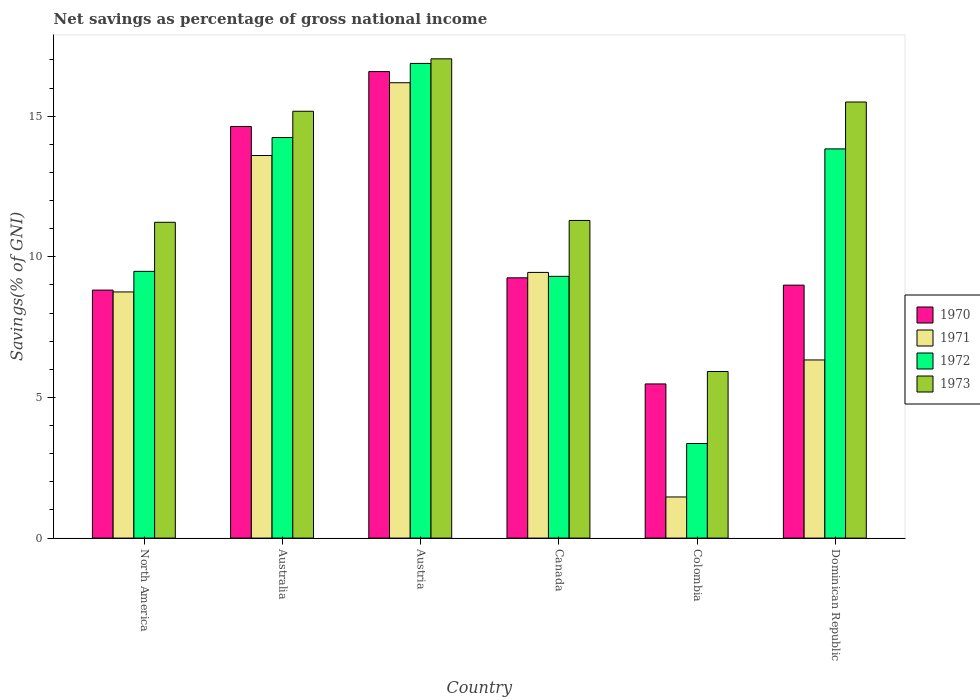How many different coloured bars are there?
Provide a short and direct response. 4. How many groups of bars are there?
Give a very brief answer. 6. Are the number of bars on each tick of the X-axis equal?
Keep it short and to the point. Yes. How many bars are there on the 6th tick from the right?
Your answer should be compact. 4. What is the total savings in 1972 in Colombia?
Ensure brevity in your answer.  3.36. Across all countries, what is the maximum total savings in 1973?
Give a very brief answer. 17.04. Across all countries, what is the minimum total savings in 1973?
Your answer should be compact. 5.92. In which country was the total savings in 1971 maximum?
Your answer should be compact. Austria. What is the total total savings in 1970 in the graph?
Your response must be concise. 63.77. What is the difference between the total savings in 1972 in Austria and that in Dominican Republic?
Your response must be concise. 3.04. What is the difference between the total savings in 1971 in Australia and the total savings in 1972 in Dominican Republic?
Give a very brief answer. -0.24. What is the average total savings in 1972 per country?
Your response must be concise. 11.19. What is the difference between the total savings of/in 1972 and total savings of/in 1971 in North America?
Ensure brevity in your answer.  0.73. What is the ratio of the total savings in 1970 in Canada to that in Dominican Republic?
Give a very brief answer. 1.03. Is the total savings in 1971 in Canada less than that in Dominican Republic?
Make the answer very short. No. What is the difference between the highest and the second highest total savings in 1973?
Give a very brief answer. 1.86. What is the difference between the highest and the lowest total savings in 1973?
Ensure brevity in your answer.  11.12. In how many countries, is the total savings in 1973 greater than the average total savings in 1973 taken over all countries?
Your answer should be very brief. 3. What does the 2nd bar from the right in Austria represents?
Your answer should be compact. 1972. What is the difference between two consecutive major ticks on the Y-axis?
Keep it short and to the point. 5. Does the graph contain grids?
Ensure brevity in your answer.  No. Where does the legend appear in the graph?
Your answer should be compact. Center right. How many legend labels are there?
Your answer should be compact. 4. How are the legend labels stacked?
Your answer should be compact. Vertical. What is the title of the graph?
Make the answer very short. Net savings as percentage of gross national income. What is the label or title of the Y-axis?
Keep it short and to the point. Savings(% of GNI). What is the Savings(% of GNI) of 1970 in North America?
Your answer should be very brief. 8.82. What is the Savings(% of GNI) of 1971 in North America?
Your response must be concise. 8.75. What is the Savings(% of GNI) in 1972 in North America?
Give a very brief answer. 9.48. What is the Savings(% of GNI) in 1973 in North America?
Provide a succinct answer. 11.23. What is the Savings(% of GNI) in 1970 in Australia?
Provide a succinct answer. 14.63. What is the Savings(% of GNI) of 1971 in Australia?
Provide a short and direct response. 13.6. What is the Savings(% of GNI) of 1972 in Australia?
Make the answer very short. 14.24. What is the Savings(% of GNI) of 1973 in Australia?
Make the answer very short. 15.18. What is the Savings(% of GNI) in 1970 in Austria?
Offer a very short reply. 16.59. What is the Savings(% of GNI) of 1971 in Austria?
Offer a very short reply. 16.19. What is the Savings(% of GNI) in 1972 in Austria?
Offer a very short reply. 16.88. What is the Savings(% of GNI) in 1973 in Austria?
Your answer should be very brief. 17.04. What is the Savings(% of GNI) in 1970 in Canada?
Give a very brief answer. 9.25. What is the Savings(% of GNI) of 1971 in Canada?
Offer a terse response. 9.45. What is the Savings(% of GNI) in 1972 in Canada?
Give a very brief answer. 9.31. What is the Savings(% of GNI) of 1973 in Canada?
Make the answer very short. 11.29. What is the Savings(% of GNI) of 1970 in Colombia?
Your answer should be compact. 5.48. What is the Savings(% of GNI) in 1971 in Colombia?
Give a very brief answer. 1.46. What is the Savings(% of GNI) of 1972 in Colombia?
Make the answer very short. 3.36. What is the Savings(% of GNI) in 1973 in Colombia?
Provide a short and direct response. 5.92. What is the Savings(% of GNI) in 1970 in Dominican Republic?
Your response must be concise. 8.99. What is the Savings(% of GNI) in 1971 in Dominican Republic?
Offer a terse response. 6.33. What is the Savings(% of GNI) in 1972 in Dominican Republic?
Provide a succinct answer. 13.84. What is the Savings(% of GNI) of 1973 in Dominican Republic?
Offer a very short reply. 15.5. Across all countries, what is the maximum Savings(% of GNI) of 1970?
Offer a very short reply. 16.59. Across all countries, what is the maximum Savings(% of GNI) of 1971?
Your answer should be compact. 16.19. Across all countries, what is the maximum Savings(% of GNI) in 1972?
Ensure brevity in your answer.  16.88. Across all countries, what is the maximum Savings(% of GNI) in 1973?
Provide a succinct answer. 17.04. Across all countries, what is the minimum Savings(% of GNI) of 1970?
Provide a short and direct response. 5.48. Across all countries, what is the minimum Savings(% of GNI) in 1971?
Your response must be concise. 1.46. Across all countries, what is the minimum Savings(% of GNI) in 1972?
Keep it short and to the point. 3.36. Across all countries, what is the minimum Savings(% of GNI) of 1973?
Your answer should be very brief. 5.92. What is the total Savings(% of GNI) of 1970 in the graph?
Provide a succinct answer. 63.77. What is the total Savings(% of GNI) in 1971 in the graph?
Ensure brevity in your answer.  55.79. What is the total Savings(% of GNI) in 1972 in the graph?
Offer a very short reply. 67.11. What is the total Savings(% of GNI) of 1973 in the graph?
Keep it short and to the point. 76.17. What is the difference between the Savings(% of GNI) of 1970 in North America and that in Australia?
Ensure brevity in your answer.  -5.82. What is the difference between the Savings(% of GNI) of 1971 in North America and that in Australia?
Provide a succinct answer. -4.85. What is the difference between the Savings(% of GNI) of 1972 in North America and that in Australia?
Provide a succinct answer. -4.76. What is the difference between the Savings(% of GNI) in 1973 in North America and that in Australia?
Make the answer very short. -3.95. What is the difference between the Savings(% of GNI) in 1970 in North America and that in Austria?
Offer a terse response. -7.77. What is the difference between the Savings(% of GNI) of 1971 in North America and that in Austria?
Provide a succinct answer. -7.44. What is the difference between the Savings(% of GNI) of 1972 in North America and that in Austria?
Give a very brief answer. -7.39. What is the difference between the Savings(% of GNI) in 1973 in North America and that in Austria?
Provide a succinct answer. -5.81. What is the difference between the Savings(% of GNI) in 1970 in North America and that in Canada?
Give a very brief answer. -0.44. What is the difference between the Savings(% of GNI) of 1971 in North America and that in Canada?
Your answer should be compact. -0.69. What is the difference between the Savings(% of GNI) in 1972 in North America and that in Canada?
Provide a short and direct response. 0.18. What is the difference between the Savings(% of GNI) in 1973 in North America and that in Canada?
Provide a short and direct response. -0.07. What is the difference between the Savings(% of GNI) in 1970 in North America and that in Colombia?
Make the answer very short. 3.34. What is the difference between the Savings(% of GNI) in 1971 in North America and that in Colombia?
Give a very brief answer. 7.29. What is the difference between the Savings(% of GNI) in 1972 in North America and that in Colombia?
Your response must be concise. 6.12. What is the difference between the Savings(% of GNI) of 1973 in North America and that in Colombia?
Provide a succinct answer. 5.31. What is the difference between the Savings(% of GNI) in 1970 in North America and that in Dominican Republic?
Ensure brevity in your answer.  -0.18. What is the difference between the Savings(% of GNI) of 1971 in North America and that in Dominican Republic?
Offer a terse response. 2.42. What is the difference between the Savings(% of GNI) in 1972 in North America and that in Dominican Republic?
Your response must be concise. -4.35. What is the difference between the Savings(% of GNI) in 1973 in North America and that in Dominican Republic?
Keep it short and to the point. -4.28. What is the difference between the Savings(% of GNI) in 1970 in Australia and that in Austria?
Your response must be concise. -1.95. What is the difference between the Savings(% of GNI) of 1971 in Australia and that in Austria?
Your answer should be compact. -2.59. What is the difference between the Savings(% of GNI) in 1972 in Australia and that in Austria?
Make the answer very short. -2.64. What is the difference between the Savings(% of GNI) in 1973 in Australia and that in Austria?
Your answer should be compact. -1.86. What is the difference between the Savings(% of GNI) in 1970 in Australia and that in Canada?
Offer a very short reply. 5.38. What is the difference between the Savings(% of GNI) in 1971 in Australia and that in Canada?
Provide a succinct answer. 4.16. What is the difference between the Savings(% of GNI) in 1972 in Australia and that in Canada?
Your answer should be very brief. 4.93. What is the difference between the Savings(% of GNI) in 1973 in Australia and that in Canada?
Your response must be concise. 3.88. What is the difference between the Savings(% of GNI) of 1970 in Australia and that in Colombia?
Your answer should be very brief. 9.15. What is the difference between the Savings(% of GNI) of 1971 in Australia and that in Colombia?
Your answer should be very brief. 12.14. What is the difference between the Savings(% of GNI) in 1972 in Australia and that in Colombia?
Keep it short and to the point. 10.88. What is the difference between the Savings(% of GNI) of 1973 in Australia and that in Colombia?
Your answer should be very brief. 9.25. What is the difference between the Savings(% of GNI) of 1970 in Australia and that in Dominican Republic?
Offer a very short reply. 5.64. What is the difference between the Savings(% of GNI) in 1971 in Australia and that in Dominican Republic?
Keep it short and to the point. 7.27. What is the difference between the Savings(% of GNI) in 1972 in Australia and that in Dominican Republic?
Provide a short and direct response. 0.4. What is the difference between the Savings(% of GNI) in 1973 in Australia and that in Dominican Republic?
Give a very brief answer. -0.33. What is the difference between the Savings(% of GNI) of 1970 in Austria and that in Canada?
Your answer should be very brief. 7.33. What is the difference between the Savings(% of GNI) in 1971 in Austria and that in Canada?
Provide a succinct answer. 6.74. What is the difference between the Savings(% of GNI) of 1972 in Austria and that in Canada?
Your answer should be very brief. 7.57. What is the difference between the Savings(% of GNI) of 1973 in Austria and that in Canada?
Ensure brevity in your answer.  5.75. What is the difference between the Savings(% of GNI) in 1970 in Austria and that in Colombia?
Provide a succinct answer. 11.11. What is the difference between the Savings(% of GNI) in 1971 in Austria and that in Colombia?
Offer a very short reply. 14.73. What is the difference between the Savings(% of GNI) of 1972 in Austria and that in Colombia?
Provide a short and direct response. 13.51. What is the difference between the Savings(% of GNI) of 1973 in Austria and that in Colombia?
Your response must be concise. 11.12. What is the difference between the Savings(% of GNI) of 1970 in Austria and that in Dominican Republic?
Offer a terse response. 7.59. What is the difference between the Savings(% of GNI) in 1971 in Austria and that in Dominican Republic?
Give a very brief answer. 9.86. What is the difference between the Savings(% of GNI) of 1972 in Austria and that in Dominican Republic?
Ensure brevity in your answer.  3.04. What is the difference between the Savings(% of GNI) of 1973 in Austria and that in Dominican Republic?
Make the answer very short. 1.54. What is the difference between the Savings(% of GNI) in 1970 in Canada and that in Colombia?
Your answer should be very brief. 3.77. What is the difference between the Savings(% of GNI) in 1971 in Canada and that in Colombia?
Provide a short and direct response. 7.98. What is the difference between the Savings(% of GNI) in 1972 in Canada and that in Colombia?
Keep it short and to the point. 5.94. What is the difference between the Savings(% of GNI) in 1973 in Canada and that in Colombia?
Your response must be concise. 5.37. What is the difference between the Savings(% of GNI) in 1970 in Canada and that in Dominican Republic?
Keep it short and to the point. 0.26. What is the difference between the Savings(% of GNI) of 1971 in Canada and that in Dominican Republic?
Make the answer very short. 3.11. What is the difference between the Savings(% of GNI) in 1972 in Canada and that in Dominican Republic?
Offer a terse response. -4.53. What is the difference between the Savings(% of GNI) of 1973 in Canada and that in Dominican Republic?
Provide a short and direct response. -4.21. What is the difference between the Savings(% of GNI) of 1970 in Colombia and that in Dominican Republic?
Make the answer very short. -3.51. What is the difference between the Savings(% of GNI) of 1971 in Colombia and that in Dominican Republic?
Your answer should be compact. -4.87. What is the difference between the Savings(% of GNI) of 1972 in Colombia and that in Dominican Republic?
Keep it short and to the point. -10.47. What is the difference between the Savings(% of GNI) in 1973 in Colombia and that in Dominican Republic?
Offer a terse response. -9.58. What is the difference between the Savings(% of GNI) of 1970 in North America and the Savings(% of GNI) of 1971 in Australia?
Make the answer very short. -4.78. What is the difference between the Savings(% of GNI) in 1970 in North America and the Savings(% of GNI) in 1972 in Australia?
Offer a terse response. -5.42. What is the difference between the Savings(% of GNI) in 1970 in North America and the Savings(% of GNI) in 1973 in Australia?
Provide a succinct answer. -6.36. What is the difference between the Savings(% of GNI) in 1971 in North America and the Savings(% of GNI) in 1972 in Australia?
Offer a terse response. -5.49. What is the difference between the Savings(% of GNI) in 1971 in North America and the Savings(% of GNI) in 1973 in Australia?
Your response must be concise. -6.42. What is the difference between the Savings(% of GNI) of 1972 in North America and the Savings(% of GNI) of 1973 in Australia?
Your response must be concise. -5.69. What is the difference between the Savings(% of GNI) of 1970 in North America and the Savings(% of GNI) of 1971 in Austria?
Make the answer very short. -7.37. What is the difference between the Savings(% of GNI) of 1970 in North America and the Savings(% of GNI) of 1972 in Austria?
Your response must be concise. -8.06. What is the difference between the Savings(% of GNI) of 1970 in North America and the Savings(% of GNI) of 1973 in Austria?
Provide a short and direct response. -8.22. What is the difference between the Savings(% of GNI) of 1971 in North America and the Savings(% of GNI) of 1972 in Austria?
Make the answer very short. -8.12. What is the difference between the Savings(% of GNI) of 1971 in North America and the Savings(% of GNI) of 1973 in Austria?
Give a very brief answer. -8.29. What is the difference between the Savings(% of GNI) of 1972 in North America and the Savings(% of GNI) of 1973 in Austria?
Offer a very short reply. -7.56. What is the difference between the Savings(% of GNI) in 1970 in North America and the Savings(% of GNI) in 1971 in Canada?
Offer a terse response. -0.63. What is the difference between the Savings(% of GNI) in 1970 in North America and the Savings(% of GNI) in 1972 in Canada?
Provide a short and direct response. -0.49. What is the difference between the Savings(% of GNI) in 1970 in North America and the Savings(% of GNI) in 1973 in Canada?
Give a very brief answer. -2.48. What is the difference between the Savings(% of GNI) of 1971 in North America and the Savings(% of GNI) of 1972 in Canada?
Offer a terse response. -0.55. What is the difference between the Savings(% of GNI) of 1971 in North America and the Savings(% of GNI) of 1973 in Canada?
Provide a short and direct response. -2.54. What is the difference between the Savings(% of GNI) in 1972 in North America and the Savings(% of GNI) in 1973 in Canada?
Ensure brevity in your answer.  -1.81. What is the difference between the Savings(% of GNI) in 1970 in North America and the Savings(% of GNI) in 1971 in Colombia?
Your answer should be compact. 7.36. What is the difference between the Savings(% of GNI) in 1970 in North America and the Savings(% of GNI) in 1972 in Colombia?
Ensure brevity in your answer.  5.45. What is the difference between the Savings(% of GNI) of 1970 in North America and the Savings(% of GNI) of 1973 in Colombia?
Give a very brief answer. 2.89. What is the difference between the Savings(% of GNI) in 1971 in North America and the Savings(% of GNI) in 1972 in Colombia?
Your response must be concise. 5.39. What is the difference between the Savings(% of GNI) in 1971 in North America and the Savings(% of GNI) in 1973 in Colombia?
Give a very brief answer. 2.83. What is the difference between the Savings(% of GNI) of 1972 in North America and the Savings(% of GNI) of 1973 in Colombia?
Provide a short and direct response. 3.56. What is the difference between the Savings(% of GNI) of 1970 in North America and the Savings(% of GNI) of 1971 in Dominican Republic?
Give a very brief answer. 2.48. What is the difference between the Savings(% of GNI) of 1970 in North America and the Savings(% of GNI) of 1972 in Dominican Republic?
Keep it short and to the point. -5.02. What is the difference between the Savings(% of GNI) in 1970 in North America and the Savings(% of GNI) in 1973 in Dominican Republic?
Provide a short and direct response. -6.69. What is the difference between the Savings(% of GNI) of 1971 in North America and the Savings(% of GNI) of 1972 in Dominican Republic?
Offer a very short reply. -5.09. What is the difference between the Savings(% of GNI) of 1971 in North America and the Savings(% of GNI) of 1973 in Dominican Republic?
Your answer should be very brief. -6.75. What is the difference between the Savings(% of GNI) in 1972 in North America and the Savings(% of GNI) in 1973 in Dominican Republic?
Give a very brief answer. -6.02. What is the difference between the Savings(% of GNI) of 1970 in Australia and the Savings(% of GNI) of 1971 in Austria?
Your answer should be compact. -1.55. What is the difference between the Savings(% of GNI) in 1970 in Australia and the Savings(% of GNI) in 1972 in Austria?
Provide a succinct answer. -2.24. What is the difference between the Savings(% of GNI) in 1970 in Australia and the Savings(% of GNI) in 1973 in Austria?
Provide a succinct answer. -2.4. What is the difference between the Savings(% of GNI) of 1971 in Australia and the Savings(% of GNI) of 1972 in Austria?
Offer a very short reply. -3.27. What is the difference between the Savings(% of GNI) of 1971 in Australia and the Savings(% of GNI) of 1973 in Austria?
Your response must be concise. -3.44. What is the difference between the Savings(% of GNI) of 1972 in Australia and the Savings(% of GNI) of 1973 in Austria?
Provide a short and direct response. -2.8. What is the difference between the Savings(% of GNI) of 1970 in Australia and the Savings(% of GNI) of 1971 in Canada?
Your response must be concise. 5.19. What is the difference between the Savings(% of GNI) in 1970 in Australia and the Savings(% of GNI) in 1972 in Canada?
Keep it short and to the point. 5.33. What is the difference between the Savings(% of GNI) of 1970 in Australia and the Savings(% of GNI) of 1973 in Canada?
Keep it short and to the point. 3.34. What is the difference between the Savings(% of GNI) in 1971 in Australia and the Savings(% of GNI) in 1972 in Canada?
Give a very brief answer. 4.3. What is the difference between the Savings(% of GNI) in 1971 in Australia and the Savings(% of GNI) in 1973 in Canada?
Ensure brevity in your answer.  2.31. What is the difference between the Savings(% of GNI) in 1972 in Australia and the Savings(% of GNI) in 1973 in Canada?
Provide a succinct answer. 2.95. What is the difference between the Savings(% of GNI) of 1970 in Australia and the Savings(% of GNI) of 1971 in Colombia?
Offer a terse response. 13.17. What is the difference between the Savings(% of GNI) of 1970 in Australia and the Savings(% of GNI) of 1972 in Colombia?
Ensure brevity in your answer.  11.27. What is the difference between the Savings(% of GNI) in 1970 in Australia and the Savings(% of GNI) in 1973 in Colombia?
Keep it short and to the point. 8.71. What is the difference between the Savings(% of GNI) of 1971 in Australia and the Savings(% of GNI) of 1972 in Colombia?
Your response must be concise. 10.24. What is the difference between the Savings(% of GNI) in 1971 in Australia and the Savings(% of GNI) in 1973 in Colombia?
Offer a terse response. 7.68. What is the difference between the Savings(% of GNI) of 1972 in Australia and the Savings(% of GNI) of 1973 in Colombia?
Your answer should be very brief. 8.32. What is the difference between the Savings(% of GNI) of 1970 in Australia and the Savings(% of GNI) of 1971 in Dominican Republic?
Offer a very short reply. 8.3. What is the difference between the Savings(% of GNI) of 1970 in Australia and the Savings(% of GNI) of 1972 in Dominican Republic?
Your answer should be compact. 0.8. What is the difference between the Savings(% of GNI) in 1970 in Australia and the Savings(% of GNI) in 1973 in Dominican Republic?
Offer a terse response. -0.87. What is the difference between the Savings(% of GNI) in 1971 in Australia and the Savings(% of GNI) in 1972 in Dominican Republic?
Provide a succinct answer. -0.24. What is the difference between the Savings(% of GNI) in 1971 in Australia and the Savings(% of GNI) in 1973 in Dominican Republic?
Keep it short and to the point. -1.9. What is the difference between the Savings(% of GNI) in 1972 in Australia and the Savings(% of GNI) in 1973 in Dominican Republic?
Your answer should be compact. -1.26. What is the difference between the Savings(% of GNI) in 1970 in Austria and the Savings(% of GNI) in 1971 in Canada?
Your answer should be very brief. 7.14. What is the difference between the Savings(% of GNI) of 1970 in Austria and the Savings(% of GNI) of 1972 in Canada?
Give a very brief answer. 7.28. What is the difference between the Savings(% of GNI) of 1970 in Austria and the Savings(% of GNI) of 1973 in Canada?
Your answer should be very brief. 5.29. What is the difference between the Savings(% of GNI) in 1971 in Austria and the Savings(% of GNI) in 1972 in Canada?
Your response must be concise. 6.88. What is the difference between the Savings(% of GNI) in 1971 in Austria and the Savings(% of GNI) in 1973 in Canada?
Provide a succinct answer. 4.9. What is the difference between the Savings(% of GNI) of 1972 in Austria and the Savings(% of GNI) of 1973 in Canada?
Offer a terse response. 5.58. What is the difference between the Savings(% of GNI) in 1970 in Austria and the Savings(% of GNI) in 1971 in Colombia?
Keep it short and to the point. 15.12. What is the difference between the Savings(% of GNI) in 1970 in Austria and the Savings(% of GNI) in 1972 in Colombia?
Make the answer very short. 13.22. What is the difference between the Savings(% of GNI) of 1970 in Austria and the Savings(% of GNI) of 1973 in Colombia?
Ensure brevity in your answer.  10.66. What is the difference between the Savings(% of GNI) of 1971 in Austria and the Savings(% of GNI) of 1972 in Colombia?
Provide a short and direct response. 12.83. What is the difference between the Savings(% of GNI) in 1971 in Austria and the Savings(% of GNI) in 1973 in Colombia?
Ensure brevity in your answer.  10.27. What is the difference between the Savings(% of GNI) in 1972 in Austria and the Savings(% of GNI) in 1973 in Colombia?
Make the answer very short. 10.95. What is the difference between the Savings(% of GNI) in 1970 in Austria and the Savings(% of GNI) in 1971 in Dominican Republic?
Offer a very short reply. 10.25. What is the difference between the Savings(% of GNI) in 1970 in Austria and the Savings(% of GNI) in 1972 in Dominican Republic?
Keep it short and to the point. 2.75. What is the difference between the Savings(% of GNI) of 1970 in Austria and the Savings(% of GNI) of 1973 in Dominican Republic?
Your answer should be compact. 1.08. What is the difference between the Savings(% of GNI) of 1971 in Austria and the Savings(% of GNI) of 1972 in Dominican Republic?
Offer a terse response. 2.35. What is the difference between the Savings(% of GNI) of 1971 in Austria and the Savings(% of GNI) of 1973 in Dominican Republic?
Your response must be concise. 0.69. What is the difference between the Savings(% of GNI) of 1972 in Austria and the Savings(% of GNI) of 1973 in Dominican Republic?
Your answer should be very brief. 1.37. What is the difference between the Savings(% of GNI) in 1970 in Canada and the Savings(% of GNI) in 1971 in Colombia?
Your answer should be compact. 7.79. What is the difference between the Savings(% of GNI) in 1970 in Canada and the Savings(% of GNI) in 1972 in Colombia?
Provide a succinct answer. 5.89. What is the difference between the Savings(% of GNI) of 1970 in Canada and the Savings(% of GNI) of 1973 in Colombia?
Your response must be concise. 3.33. What is the difference between the Savings(% of GNI) in 1971 in Canada and the Savings(% of GNI) in 1972 in Colombia?
Keep it short and to the point. 6.08. What is the difference between the Savings(% of GNI) of 1971 in Canada and the Savings(% of GNI) of 1973 in Colombia?
Your response must be concise. 3.52. What is the difference between the Savings(% of GNI) in 1972 in Canada and the Savings(% of GNI) in 1973 in Colombia?
Provide a short and direct response. 3.38. What is the difference between the Savings(% of GNI) of 1970 in Canada and the Savings(% of GNI) of 1971 in Dominican Republic?
Your response must be concise. 2.92. What is the difference between the Savings(% of GNI) in 1970 in Canada and the Savings(% of GNI) in 1972 in Dominican Republic?
Provide a short and direct response. -4.58. What is the difference between the Savings(% of GNI) in 1970 in Canada and the Savings(% of GNI) in 1973 in Dominican Republic?
Your response must be concise. -6.25. What is the difference between the Savings(% of GNI) of 1971 in Canada and the Savings(% of GNI) of 1972 in Dominican Republic?
Make the answer very short. -4.39. What is the difference between the Savings(% of GNI) of 1971 in Canada and the Savings(% of GNI) of 1973 in Dominican Republic?
Your response must be concise. -6.06. What is the difference between the Savings(% of GNI) of 1972 in Canada and the Savings(% of GNI) of 1973 in Dominican Republic?
Provide a succinct answer. -6.2. What is the difference between the Savings(% of GNI) in 1970 in Colombia and the Savings(% of GNI) in 1971 in Dominican Republic?
Offer a very short reply. -0.85. What is the difference between the Savings(% of GNI) of 1970 in Colombia and the Savings(% of GNI) of 1972 in Dominican Republic?
Ensure brevity in your answer.  -8.36. What is the difference between the Savings(% of GNI) in 1970 in Colombia and the Savings(% of GNI) in 1973 in Dominican Republic?
Make the answer very short. -10.02. What is the difference between the Savings(% of GNI) in 1971 in Colombia and the Savings(% of GNI) in 1972 in Dominican Republic?
Ensure brevity in your answer.  -12.38. What is the difference between the Savings(% of GNI) in 1971 in Colombia and the Savings(% of GNI) in 1973 in Dominican Republic?
Keep it short and to the point. -14.04. What is the difference between the Savings(% of GNI) in 1972 in Colombia and the Savings(% of GNI) in 1973 in Dominican Republic?
Your answer should be very brief. -12.14. What is the average Savings(% of GNI) of 1970 per country?
Your answer should be very brief. 10.63. What is the average Savings(% of GNI) of 1971 per country?
Offer a terse response. 9.3. What is the average Savings(% of GNI) of 1972 per country?
Keep it short and to the point. 11.19. What is the average Savings(% of GNI) of 1973 per country?
Your response must be concise. 12.69. What is the difference between the Savings(% of GNI) in 1970 and Savings(% of GNI) in 1971 in North America?
Give a very brief answer. 0.07. What is the difference between the Savings(% of GNI) in 1970 and Savings(% of GNI) in 1972 in North America?
Provide a short and direct response. -0.67. What is the difference between the Savings(% of GNI) in 1970 and Savings(% of GNI) in 1973 in North America?
Your answer should be compact. -2.41. What is the difference between the Savings(% of GNI) of 1971 and Savings(% of GNI) of 1972 in North America?
Your answer should be very brief. -0.73. What is the difference between the Savings(% of GNI) of 1971 and Savings(% of GNI) of 1973 in North America?
Your answer should be compact. -2.48. What is the difference between the Savings(% of GNI) in 1972 and Savings(% of GNI) in 1973 in North America?
Ensure brevity in your answer.  -1.74. What is the difference between the Savings(% of GNI) of 1970 and Savings(% of GNI) of 1971 in Australia?
Your answer should be compact. 1.03. What is the difference between the Savings(% of GNI) in 1970 and Savings(% of GNI) in 1972 in Australia?
Your answer should be compact. 0.39. What is the difference between the Savings(% of GNI) of 1970 and Savings(% of GNI) of 1973 in Australia?
Ensure brevity in your answer.  -0.54. What is the difference between the Savings(% of GNI) in 1971 and Savings(% of GNI) in 1972 in Australia?
Give a very brief answer. -0.64. What is the difference between the Savings(% of GNI) in 1971 and Savings(% of GNI) in 1973 in Australia?
Your response must be concise. -1.57. What is the difference between the Savings(% of GNI) of 1972 and Savings(% of GNI) of 1973 in Australia?
Offer a very short reply. -0.93. What is the difference between the Savings(% of GNI) of 1970 and Savings(% of GNI) of 1971 in Austria?
Your answer should be compact. 0.4. What is the difference between the Savings(% of GNI) in 1970 and Savings(% of GNI) in 1972 in Austria?
Offer a very short reply. -0.29. What is the difference between the Savings(% of GNI) of 1970 and Savings(% of GNI) of 1973 in Austria?
Your answer should be very brief. -0.45. What is the difference between the Savings(% of GNI) in 1971 and Savings(% of GNI) in 1972 in Austria?
Provide a short and direct response. -0.69. What is the difference between the Savings(% of GNI) of 1971 and Savings(% of GNI) of 1973 in Austria?
Offer a terse response. -0.85. What is the difference between the Savings(% of GNI) in 1972 and Savings(% of GNI) in 1973 in Austria?
Provide a short and direct response. -0.16. What is the difference between the Savings(% of GNI) of 1970 and Savings(% of GNI) of 1971 in Canada?
Offer a terse response. -0.19. What is the difference between the Savings(% of GNI) of 1970 and Savings(% of GNI) of 1972 in Canada?
Your answer should be compact. -0.05. What is the difference between the Savings(% of GNI) of 1970 and Savings(% of GNI) of 1973 in Canada?
Offer a terse response. -2.04. What is the difference between the Savings(% of GNI) of 1971 and Savings(% of GNI) of 1972 in Canada?
Your response must be concise. 0.14. What is the difference between the Savings(% of GNI) in 1971 and Savings(% of GNI) in 1973 in Canada?
Your answer should be very brief. -1.85. What is the difference between the Savings(% of GNI) in 1972 and Savings(% of GNI) in 1973 in Canada?
Your answer should be very brief. -1.99. What is the difference between the Savings(% of GNI) in 1970 and Savings(% of GNI) in 1971 in Colombia?
Offer a very short reply. 4.02. What is the difference between the Savings(% of GNI) of 1970 and Savings(% of GNI) of 1972 in Colombia?
Offer a very short reply. 2.12. What is the difference between the Savings(% of GNI) in 1970 and Savings(% of GNI) in 1973 in Colombia?
Offer a very short reply. -0.44. What is the difference between the Savings(% of GNI) in 1971 and Savings(% of GNI) in 1972 in Colombia?
Give a very brief answer. -1.9. What is the difference between the Savings(% of GNI) of 1971 and Savings(% of GNI) of 1973 in Colombia?
Make the answer very short. -4.46. What is the difference between the Savings(% of GNI) in 1972 and Savings(% of GNI) in 1973 in Colombia?
Make the answer very short. -2.56. What is the difference between the Savings(% of GNI) of 1970 and Savings(% of GNI) of 1971 in Dominican Republic?
Offer a very short reply. 2.66. What is the difference between the Savings(% of GNI) of 1970 and Savings(% of GNI) of 1972 in Dominican Republic?
Ensure brevity in your answer.  -4.84. What is the difference between the Savings(% of GNI) in 1970 and Savings(% of GNI) in 1973 in Dominican Republic?
Offer a terse response. -6.51. What is the difference between the Savings(% of GNI) in 1971 and Savings(% of GNI) in 1972 in Dominican Republic?
Make the answer very short. -7.5. What is the difference between the Savings(% of GNI) in 1971 and Savings(% of GNI) in 1973 in Dominican Republic?
Your answer should be compact. -9.17. What is the difference between the Savings(% of GNI) in 1972 and Savings(% of GNI) in 1973 in Dominican Republic?
Offer a terse response. -1.67. What is the ratio of the Savings(% of GNI) of 1970 in North America to that in Australia?
Offer a very short reply. 0.6. What is the ratio of the Savings(% of GNI) in 1971 in North America to that in Australia?
Your answer should be very brief. 0.64. What is the ratio of the Savings(% of GNI) in 1972 in North America to that in Australia?
Provide a short and direct response. 0.67. What is the ratio of the Savings(% of GNI) of 1973 in North America to that in Australia?
Keep it short and to the point. 0.74. What is the ratio of the Savings(% of GNI) in 1970 in North America to that in Austria?
Provide a succinct answer. 0.53. What is the ratio of the Savings(% of GNI) in 1971 in North America to that in Austria?
Ensure brevity in your answer.  0.54. What is the ratio of the Savings(% of GNI) in 1972 in North America to that in Austria?
Give a very brief answer. 0.56. What is the ratio of the Savings(% of GNI) of 1973 in North America to that in Austria?
Provide a succinct answer. 0.66. What is the ratio of the Savings(% of GNI) of 1970 in North America to that in Canada?
Keep it short and to the point. 0.95. What is the ratio of the Savings(% of GNI) of 1971 in North America to that in Canada?
Ensure brevity in your answer.  0.93. What is the ratio of the Savings(% of GNI) of 1972 in North America to that in Canada?
Your response must be concise. 1.02. What is the ratio of the Savings(% of GNI) of 1970 in North America to that in Colombia?
Make the answer very short. 1.61. What is the ratio of the Savings(% of GNI) in 1971 in North America to that in Colombia?
Ensure brevity in your answer.  5.98. What is the ratio of the Savings(% of GNI) in 1972 in North America to that in Colombia?
Your answer should be compact. 2.82. What is the ratio of the Savings(% of GNI) of 1973 in North America to that in Colombia?
Provide a succinct answer. 1.9. What is the ratio of the Savings(% of GNI) in 1970 in North America to that in Dominican Republic?
Offer a very short reply. 0.98. What is the ratio of the Savings(% of GNI) in 1971 in North America to that in Dominican Republic?
Make the answer very short. 1.38. What is the ratio of the Savings(% of GNI) of 1972 in North America to that in Dominican Republic?
Make the answer very short. 0.69. What is the ratio of the Savings(% of GNI) of 1973 in North America to that in Dominican Republic?
Provide a succinct answer. 0.72. What is the ratio of the Savings(% of GNI) of 1970 in Australia to that in Austria?
Keep it short and to the point. 0.88. What is the ratio of the Savings(% of GNI) in 1971 in Australia to that in Austria?
Offer a terse response. 0.84. What is the ratio of the Savings(% of GNI) in 1972 in Australia to that in Austria?
Provide a succinct answer. 0.84. What is the ratio of the Savings(% of GNI) of 1973 in Australia to that in Austria?
Provide a succinct answer. 0.89. What is the ratio of the Savings(% of GNI) of 1970 in Australia to that in Canada?
Your answer should be very brief. 1.58. What is the ratio of the Savings(% of GNI) in 1971 in Australia to that in Canada?
Your answer should be very brief. 1.44. What is the ratio of the Savings(% of GNI) of 1972 in Australia to that in Canada?
Provide a succinct answer. 1.53. What is the ratio of the Savings(% of GNI) of 1973 in Australia to that in Canada?
Provide a short and direct response. 1.34. What is the ratio of the Savings(% of GNI) in 1970 in Australia to that in Colombia?
Keep it short and to the point. 2.67. What is the ratio of the Savings(% of GNI) in 1971 in Australia to that in Colombia?
Provide a succinct answer. 9.3. What is the ratio of the Savings(% of GNI) of 1972 in Australia to that in Colombia?
Your response must be concise. 4.23. What is the ratio of the Savings(% of GNI) of 1973 in Australia to that in Colombia?
Make the answer very short. 2.56. What is the ratio of the Savings(% of GNI) of 1970 in Australia to that in Dominican Republic?
Ensure brevity in your answer.  1.63. What is the ratio of the Savings(% of GNI) of 1971 in Australia to that in Dominican Republic?
Provide a short and direct response. 2.15. What is the ratio of the Savings(% of GNI) of 1972 in Australia to that in Dominican Republic?
Offer a terse response. 1.03. What is the ratio of the Savings(% of GNI) in 1973 in Australia to that in Dominican Republic?
Your response must be concise. 0.98. What is the ratio of the Savings(% of GNI) in 1970 in Austria to that in Canada?
Your response must be concise. 1.79. What is the ratio of the Savings(% of GNI) of 1971 in Austria to that in Canada?
Make the answer very short. 1.71. What is the ratio of the Savings(% of GNI) of 1972 in Austria to that in Canada?
Ensure brevity in your answer.  1.81. What is the ratio of the Savings(% of GNI) in 1973 in Austria to that in Canada?
Provide a succinct answer. 1.51. What is the ratio of the Savings(% of GNI) of 1970 in Austria to that in Colombia?
Your answer should be very brief. 3.03. What is the ratio of the Savings(% of GNI) of 1971 in Austria to that in Colombia?
Keep it short and to the point. 11.07. What is the ratio of the Savings(% of GNI) of 1972 in Austria to that in Colombia?
Keep it short and to the point. 5.02. What is the ratio of the Savings(% of GNI) of 1973 in Austria to that in Colombia?
Make the answer very short. 2.88. What is the ratio of the Savings(% of GNI) in 1970 in Austria to that in Dominican Republic?
Your answer should be compact. 1.84. What is the ratio of the Savings(% of GNI) of 1971 in Austria to that in Dominican Republic?
Offer a terse response. 2.56. What is the ratio of the Savings(% of GNI) in 1972 in Austria to that in Dominican Republic?
Make the answer very short. 1.22. What is the ratio of the Savings(% of GNI) in 1973 in Austria to that in Dominican Republic?
Offer a terse response. 1.1. What is the ratio of the Savings(% of GNI) in 1970 in Canada to that in Colombia?
Give a very brief answer. 1.69. What is the ratio of the Savings(% of GNI) in 1971 in Canada to that in Colombia?
Ensure brevity in your answer.  6.46. What is the ratio of the Savings(% of GNI) of 1972 in Canada to that in Colombia?
Give a very brief answer. 2.77. What is the ratio of the Savings(% of GNI) in 1973 in Canada to that in Colombia?
Give a very brief answer. 1.91. What is the ratio of the Savings(% of GNI) of 1970 in Canada to that in Dominican Republic?
Provide a short and direct response. 1.03. What is the ratio of the Savings(% of GNI) of 1971 in Canada to that in Dominican Republic?
Your answer should be very brief. 1.49. What is the ratio of the Savings(% of GNI) of 1972 in Canada to that in Dominican Republic?
Your answer should be very brief. 0.67. What is the ratio of the Savings(% of GNI) of 1973 in Canada to that in Dominican Republic?
Ensure brevity in your answer.  0.73. What is the ratio of the Savings(% of GNI) of 1970 in Colombia to that in Dominican Republic?
Ensure brevity in your answer.  0.61. What is the ratio of the Savings(% of GNI) of 1971 in Colombia to that in Dominican Republic?
Give a very brief answer. 0.23. What is the ratio of the Savings(% of GNI) of 1972 in Colombia to that in Dominican Republic?
Give a very brief answer. 0.24. What is the ratio of the Savings(% of GNI) in 1973 in Colombia to that in Dominican Republic?
Offer a terse response. 0.38. What is the difference between the highest and the second highest Savings(% of GNI) in 1970?
Provide a short and direct response. 1.95. What is the difference between the highest and the second highest Savings(% of GNI) of 1971?
Keep it short and to the point. 2.59. What is the difference between the highest and the second highest Savings(% of GNI) of 1972?
Offer a terse response. 2.64. What is the difference between the highest and the second highest Savings(% of GNI) in 1973?
Provide a short and direct response. 1.54. What is the difference between the highest and the lowest Savings(% of GNI) of 1970?
Ensure brevity in your answer.  11.11. What is the difference between the highest and the lowest Savings(% of GNI) of 1971?
Your response must be concise. 14.73. What is the difference between the highest and the lowest Savings(% of GNI) of 1972?
Ensure brevity in your answer.  13.51. What is the difference between the highest and the lowest Savings(% of GNI) of 1973?
Your answer should be compact. 11.12. 